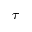Convert formula to latex. <formula><loc_0><loc_0><loc_500><loc_500>\tau</formula> 